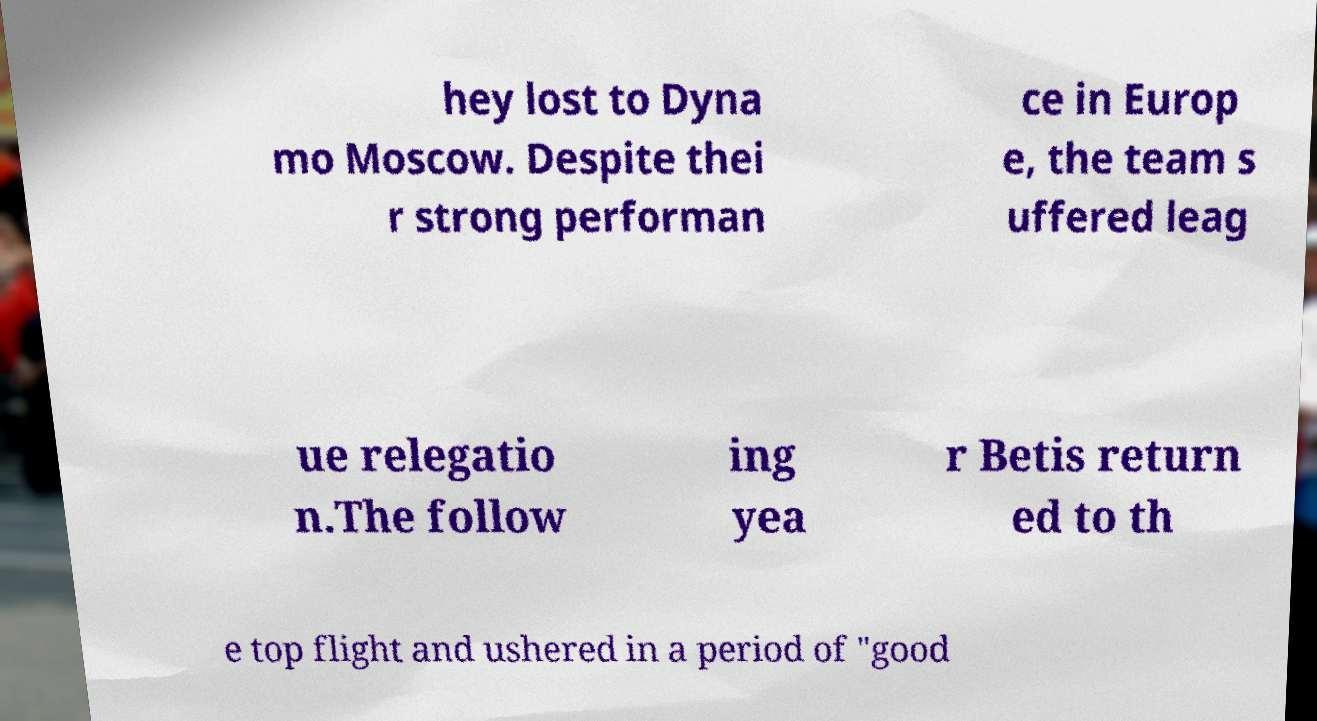Can you accurately transcribe the text from the provided image for me? hey lost to Dyna mo Moscow. Despite thei r strong performan ce in Europ e, the team s uffered leag ue relegatio n.The follow ing yea r Betis return ed to th e top flight and ushered in a period of "good 